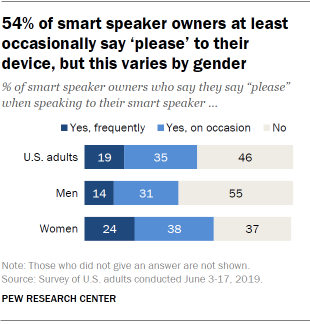Draw attention to some important aspects in this diagram. What's the difference between women and men choosing Yes on occasion?" is a grammatically correct and sentence. It is a question asking for an explanation of the difference between women and men choosing Yes on occasion. In the United States, 46% of adults choose not to have any religious affiliation. 